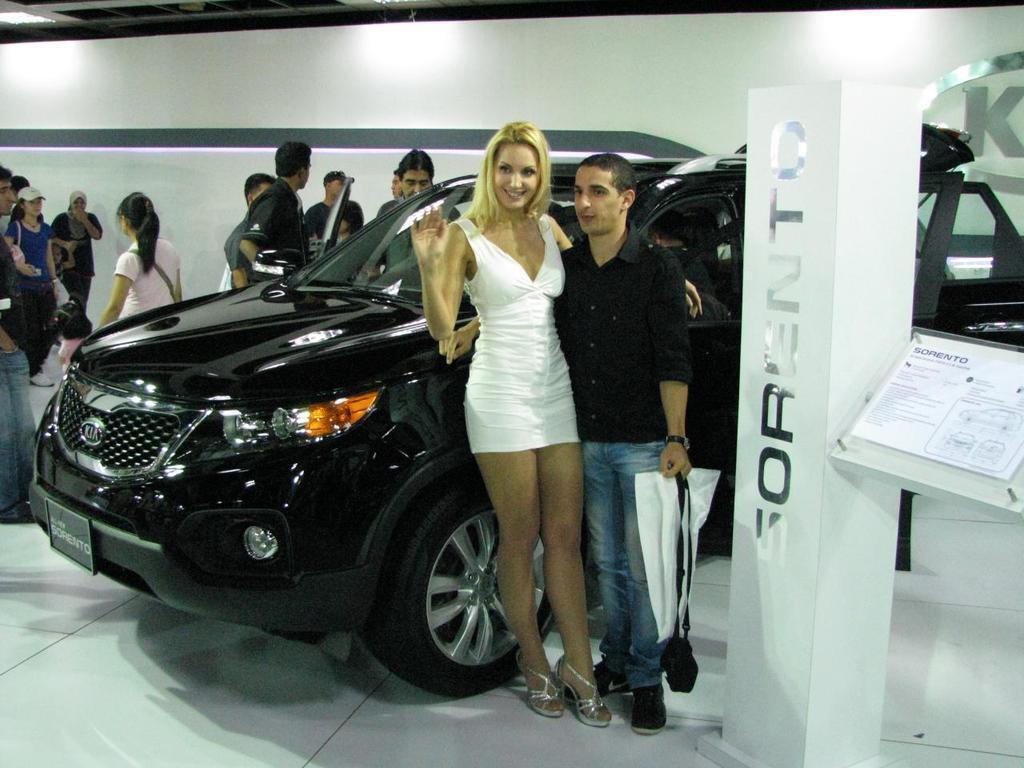Could you give a brief overview of what you see in this image? In this image there is a car. Beside the car there are a few people standing on the floor. On the right side of the image there is a pillar with some text on it. Beside the pillar there is a board with some text and drawing on it. In the background of the image there is a wall. On top of the image there are lights. 